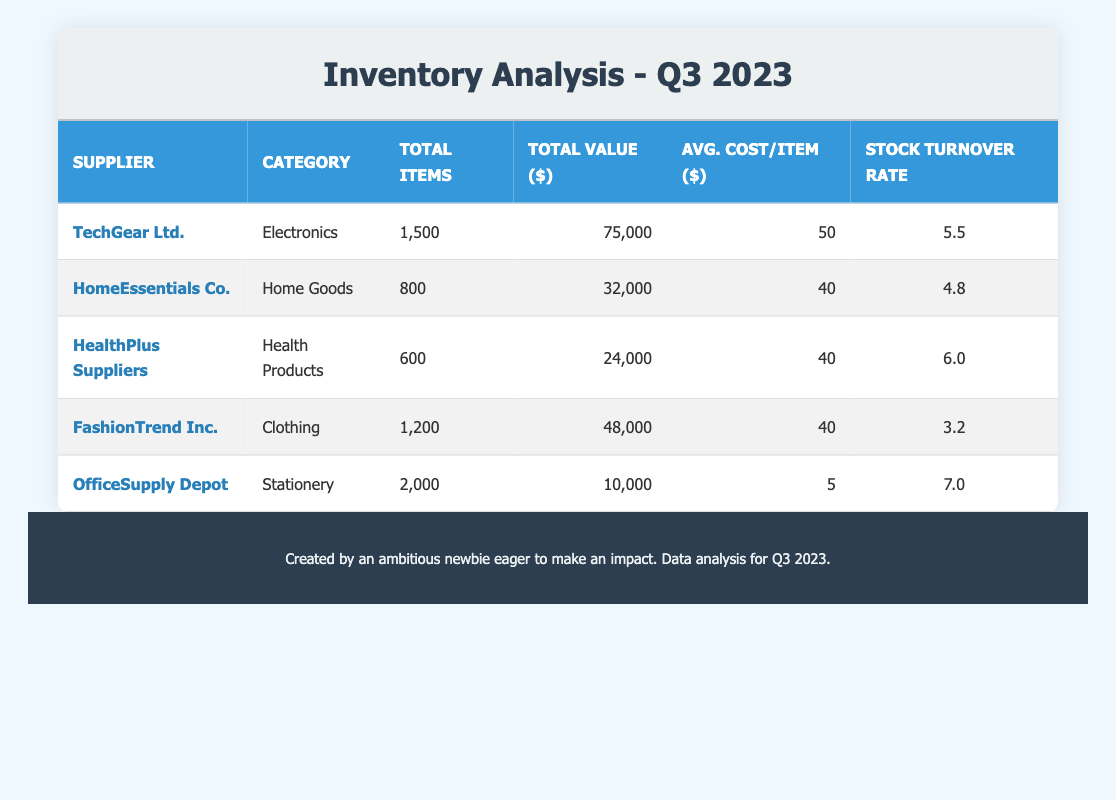What's the total value of inventory for TechGear Ltd.? The table indicates that TechGear Ltd. has a total value of $75,000 in inventory.
Answer: 75,000 How many total items does OfficeSupply Depot have? According to the table, OfficeSupply Depot has a total of 2,000 items in inventory.
Answer: 2,000 Which supplier has the highest average cost per item? Looking at the table, TechGear Ltd. has the highest average cost per item at $50.
Answer: TechGear Ltd What is the total value of items for suppliers in the Health Products category? The table indicates that HealthPlus Suppliers has a total value of $24,000, as it's the only supplier in this category.
Answer: 24,000 Is the stock turnover rate for FashionTrend Inc. greater than 4.5? The stock turnover rate for FashionTrend Inc. is 3.2, which is less than 4.5. Therefore, the statement is false.
Answer: No What is the average stock turnover rate of all suppliers? To find the average stock turnover rate, sum the stock turnover rates (5.5 + 4.8 + 6.0 + 3.2 + 7.0 = 26.5) and divide by the number of suppliers (5), resulting in 26.5 / 5 = 5.3.
Answer: 5.3 Which supplier has the lowest total value and what is it? By examining the table, OfficeSupply Depot has the lowest total value at $10,000.
Answer: OfficeSupply Depot, 10,000 How many total items are there across all suppliers? The total number of items across all suppliers can be calculated by summing the individual totals: (1500 + 800 + 600 + 1200 + 2000 = 5100).
Answer: 5,100 Which item category has the highest average cost per item? Calculating the average cost per item for each supplier shows that TechGear Ltd. has the highest average cost at $50.
Answer: Electronics 